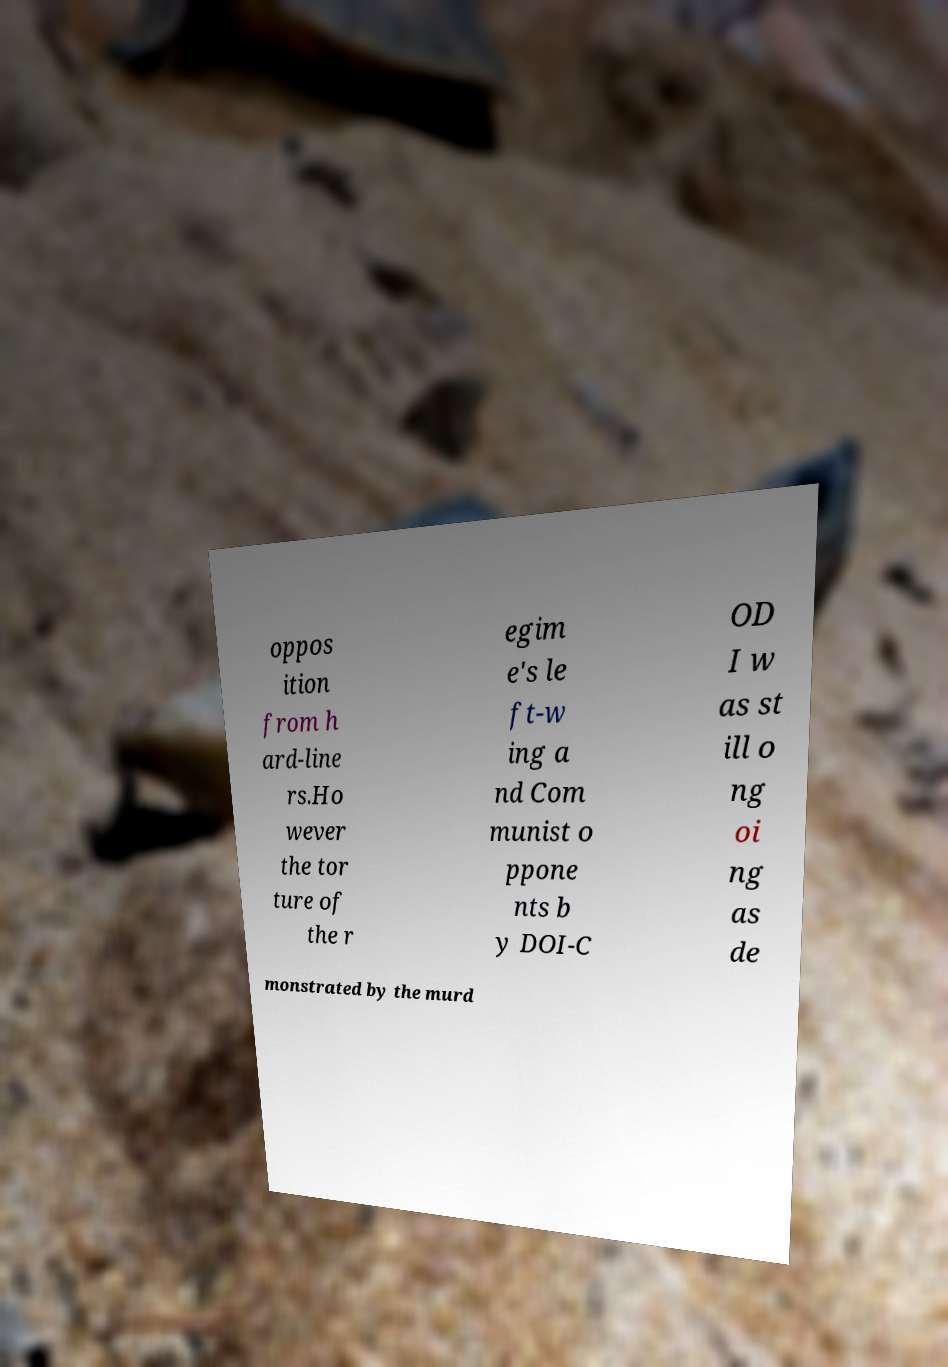Could you assist in decoding the text presented in this image and type it out clearly? oppos ition from h ard-line rs.Ho wever the tor ture of the r egim e's le ft-w ing a nd Com munist o ppone nts b y DOI-C OD I w as st ill o ng oi ng as de monstrated by the murd 